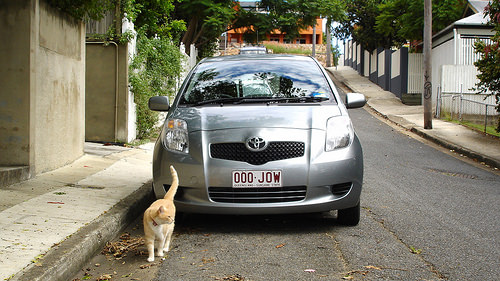<image>
Is the cat to the left of the car? No. The cat is not to the left of the car. From this viewpoint, they have a different horizontal relationship. Where is the car in relation to the cat? Is it to the left of the cat? No. The car is not to the left of the cat. From this viewpoint, they have a different horizontal relationship. 